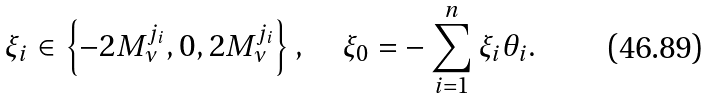Convert formula to latex. <formula><loc_0><loc_0><loc_500><loc_500>\xi _ { i } \in \left \{ - 2 M _ { \nu } ^ { j _ { i } } , 0 , 2 M _ { \nu } ^ { j _ { i } } \right \} , \quad \xi _ { 0 } = - \sum _ { i = 1 } ^ { n } \xi _ { i } \theta _ { i } .</formula> 